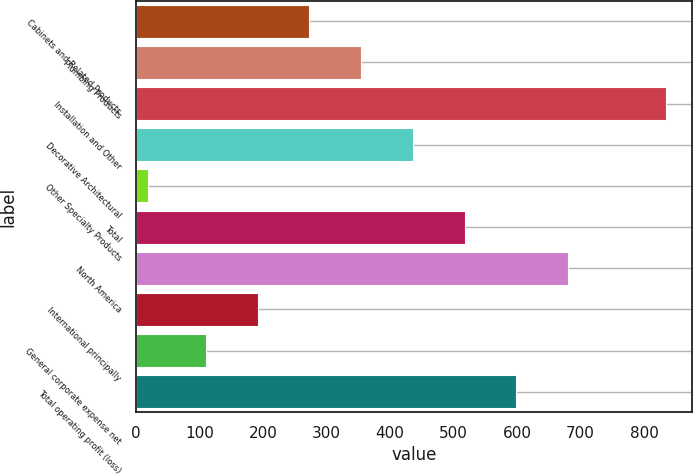<chart> <loc_0><loc_0><loc_500><loc_500><bar_chart><fcel>Cabinets and Related Products<fcel>Plumbing Products<fcel>Installation and Other<fcel>Decorative Architectural<fcel>Other Specialty Products<fcel>Total<fcel>North America<fcel>International principally<fcel>General corporate expense net<fcel>Total operating profit (loss)<nl><fcel>273<fcel>354.5<fcel>834<fcel>436<fcel>19<fcel>517.5<fcel>680.5<fcel>191.5<fcel>110<fcel>599<nl></chart> 